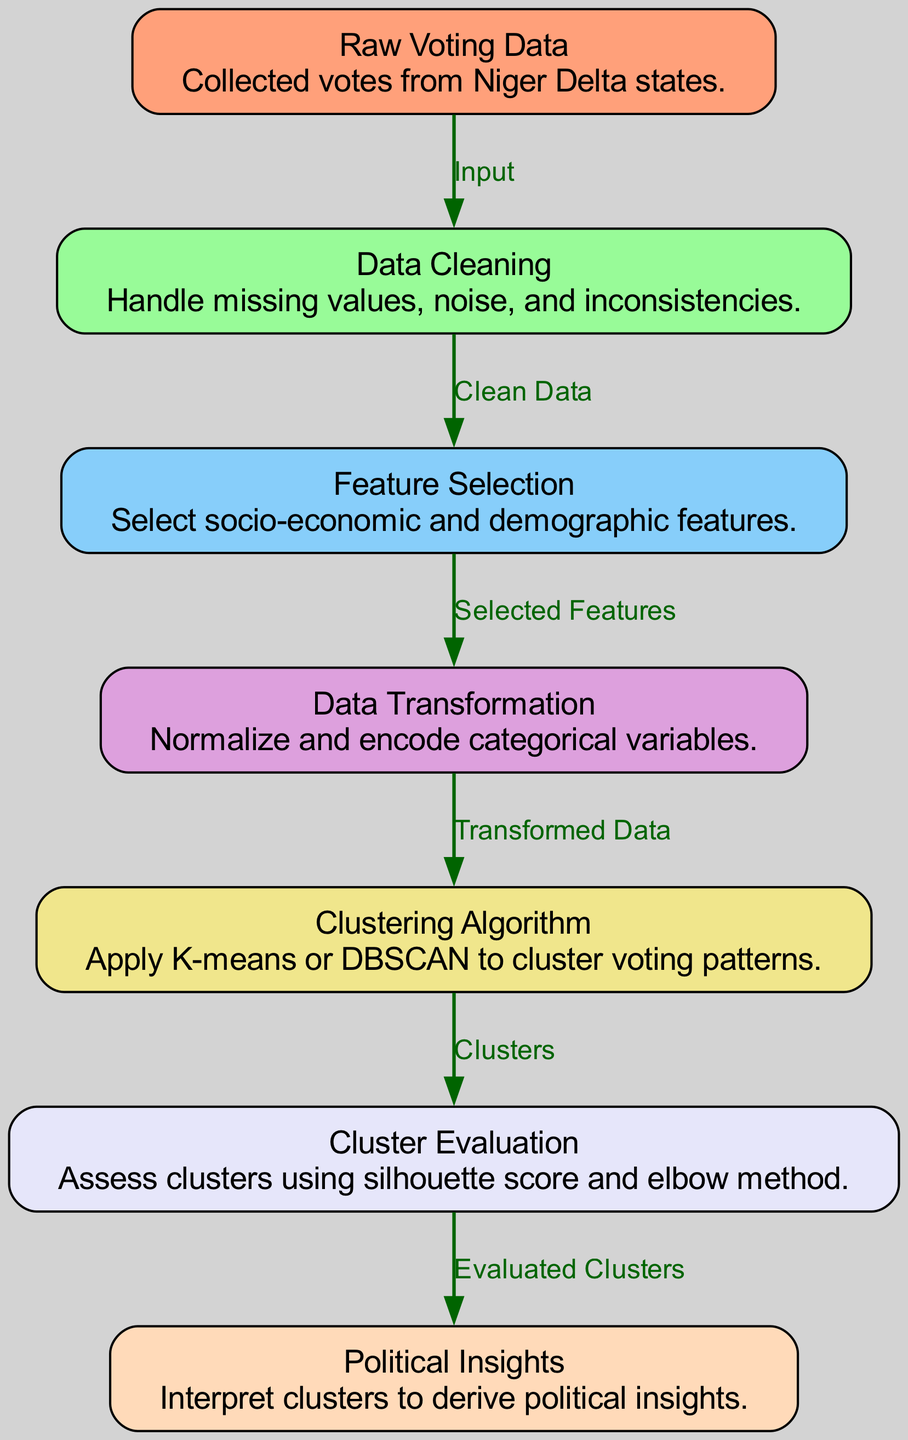What is the first node in the diagram? The first node in the diagram is labeled "Raw Voting Data," which is where the collected votes from Niger Delta states are inputted into the process.
Answer: Raw Voting Data How many edges are there in the diagram? The diagram contains six edges that represent the connections between various nodes, illustrating the flow of data processing from one stage to another.
Answer: 6 Which algorithm is applied in the fifth node? The fifth node is labeled "Clustering Algorithm," and in this step, either K-means or DBSCAN is applied to cluster voting patterns, based on the features selected in previous stages.
Answer: K-means or DBSCAN What describes the output of the fourth node? The output of the fourth node titled "Data Transformation" describes the transformed data that has been normalized and where categorical variables have been encoded, preparing it for clustering.
Answer: Transformed Data What is evaluated in the sixth node? In the sixth node, "Cluster Evaluation," the clusters created during the clustering algorithm stage are assessed using metrics such as the silhouette score and elbow method to determine their quality.
Answer: Clusters What is the final step described in the diagram? The final step described in the diagram is labeled "Political Insights," where the evaluated clusters are interpreted to derive insights into voting patterns and political behaviors in the Niger Delta.
Answer: Political Insights Which node follows "Data Cleaning"? After "Data Cleaning," which is the second node, the next node is "Feature Selection." This node focuses on selecting relevant socio-economic and demographic features for further analysis.
Answer: Feature Selection What process occurs after "Clustering Algorithm"? Once the "Clustering Algorithm" node is complete, the process moves to "Cluster Evaluation," where the created clusters undergo assessment to determine their effectiveness and relevance.
Answer: Cluster Evaluation 